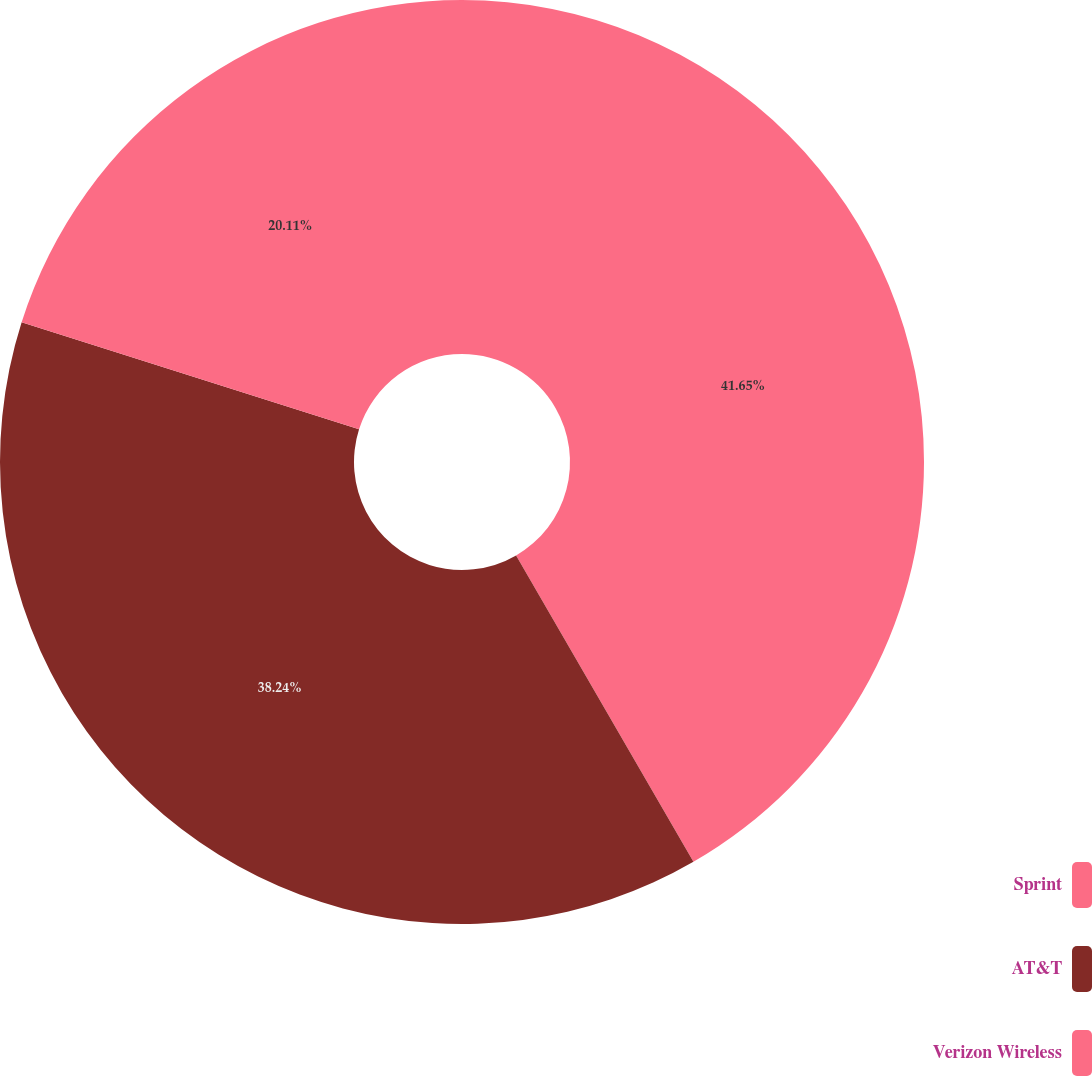<chart> <loc_0><loc_0><loc_500><loc_500><pie_chart><fcel>Sprint<fcel>AT&T<fcel>Verizon Wireless<nl><fcel>41.65%<fcel>38.24%<fcel>20.11%<nl></chart> 